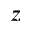Convert formula to latex. <formula><loc_0><loc_0><loc_500><loc_500>_ { z }</formula> 